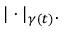<formula> <loc_0><loc_0><loc_500><loc_500>| \cdot | _ { \gamma ( t ) } .</formula> 